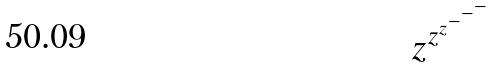Convert formula to latex. <formula><loc_0><loc_0><loc_500><loc_500>z ^ { z ^ { z ^ { - ^ { - ^ { - } } } } }</formula> 